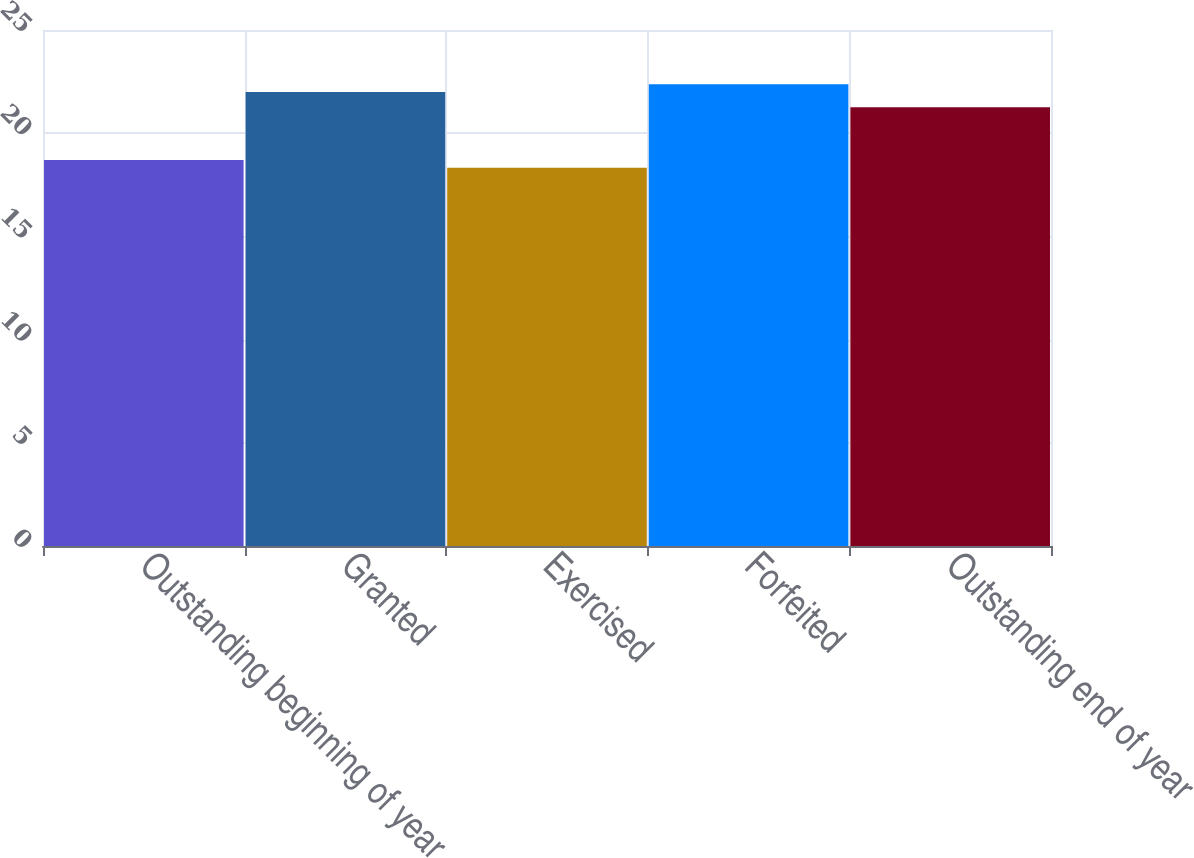Convert chart to OTSL. <chart><loc_0><loc_0><loc_500><loc_500><bar_chart><fcel>Outstanding beginning of year<fcel>Granted<fcel>Exercised<fcel>Forfeited<fcel>Outstanding end of year<nl><fcel>18.7<fcel>22<fcel>18.33<fcel>22.37<fcel>21.26<nl></chart> 